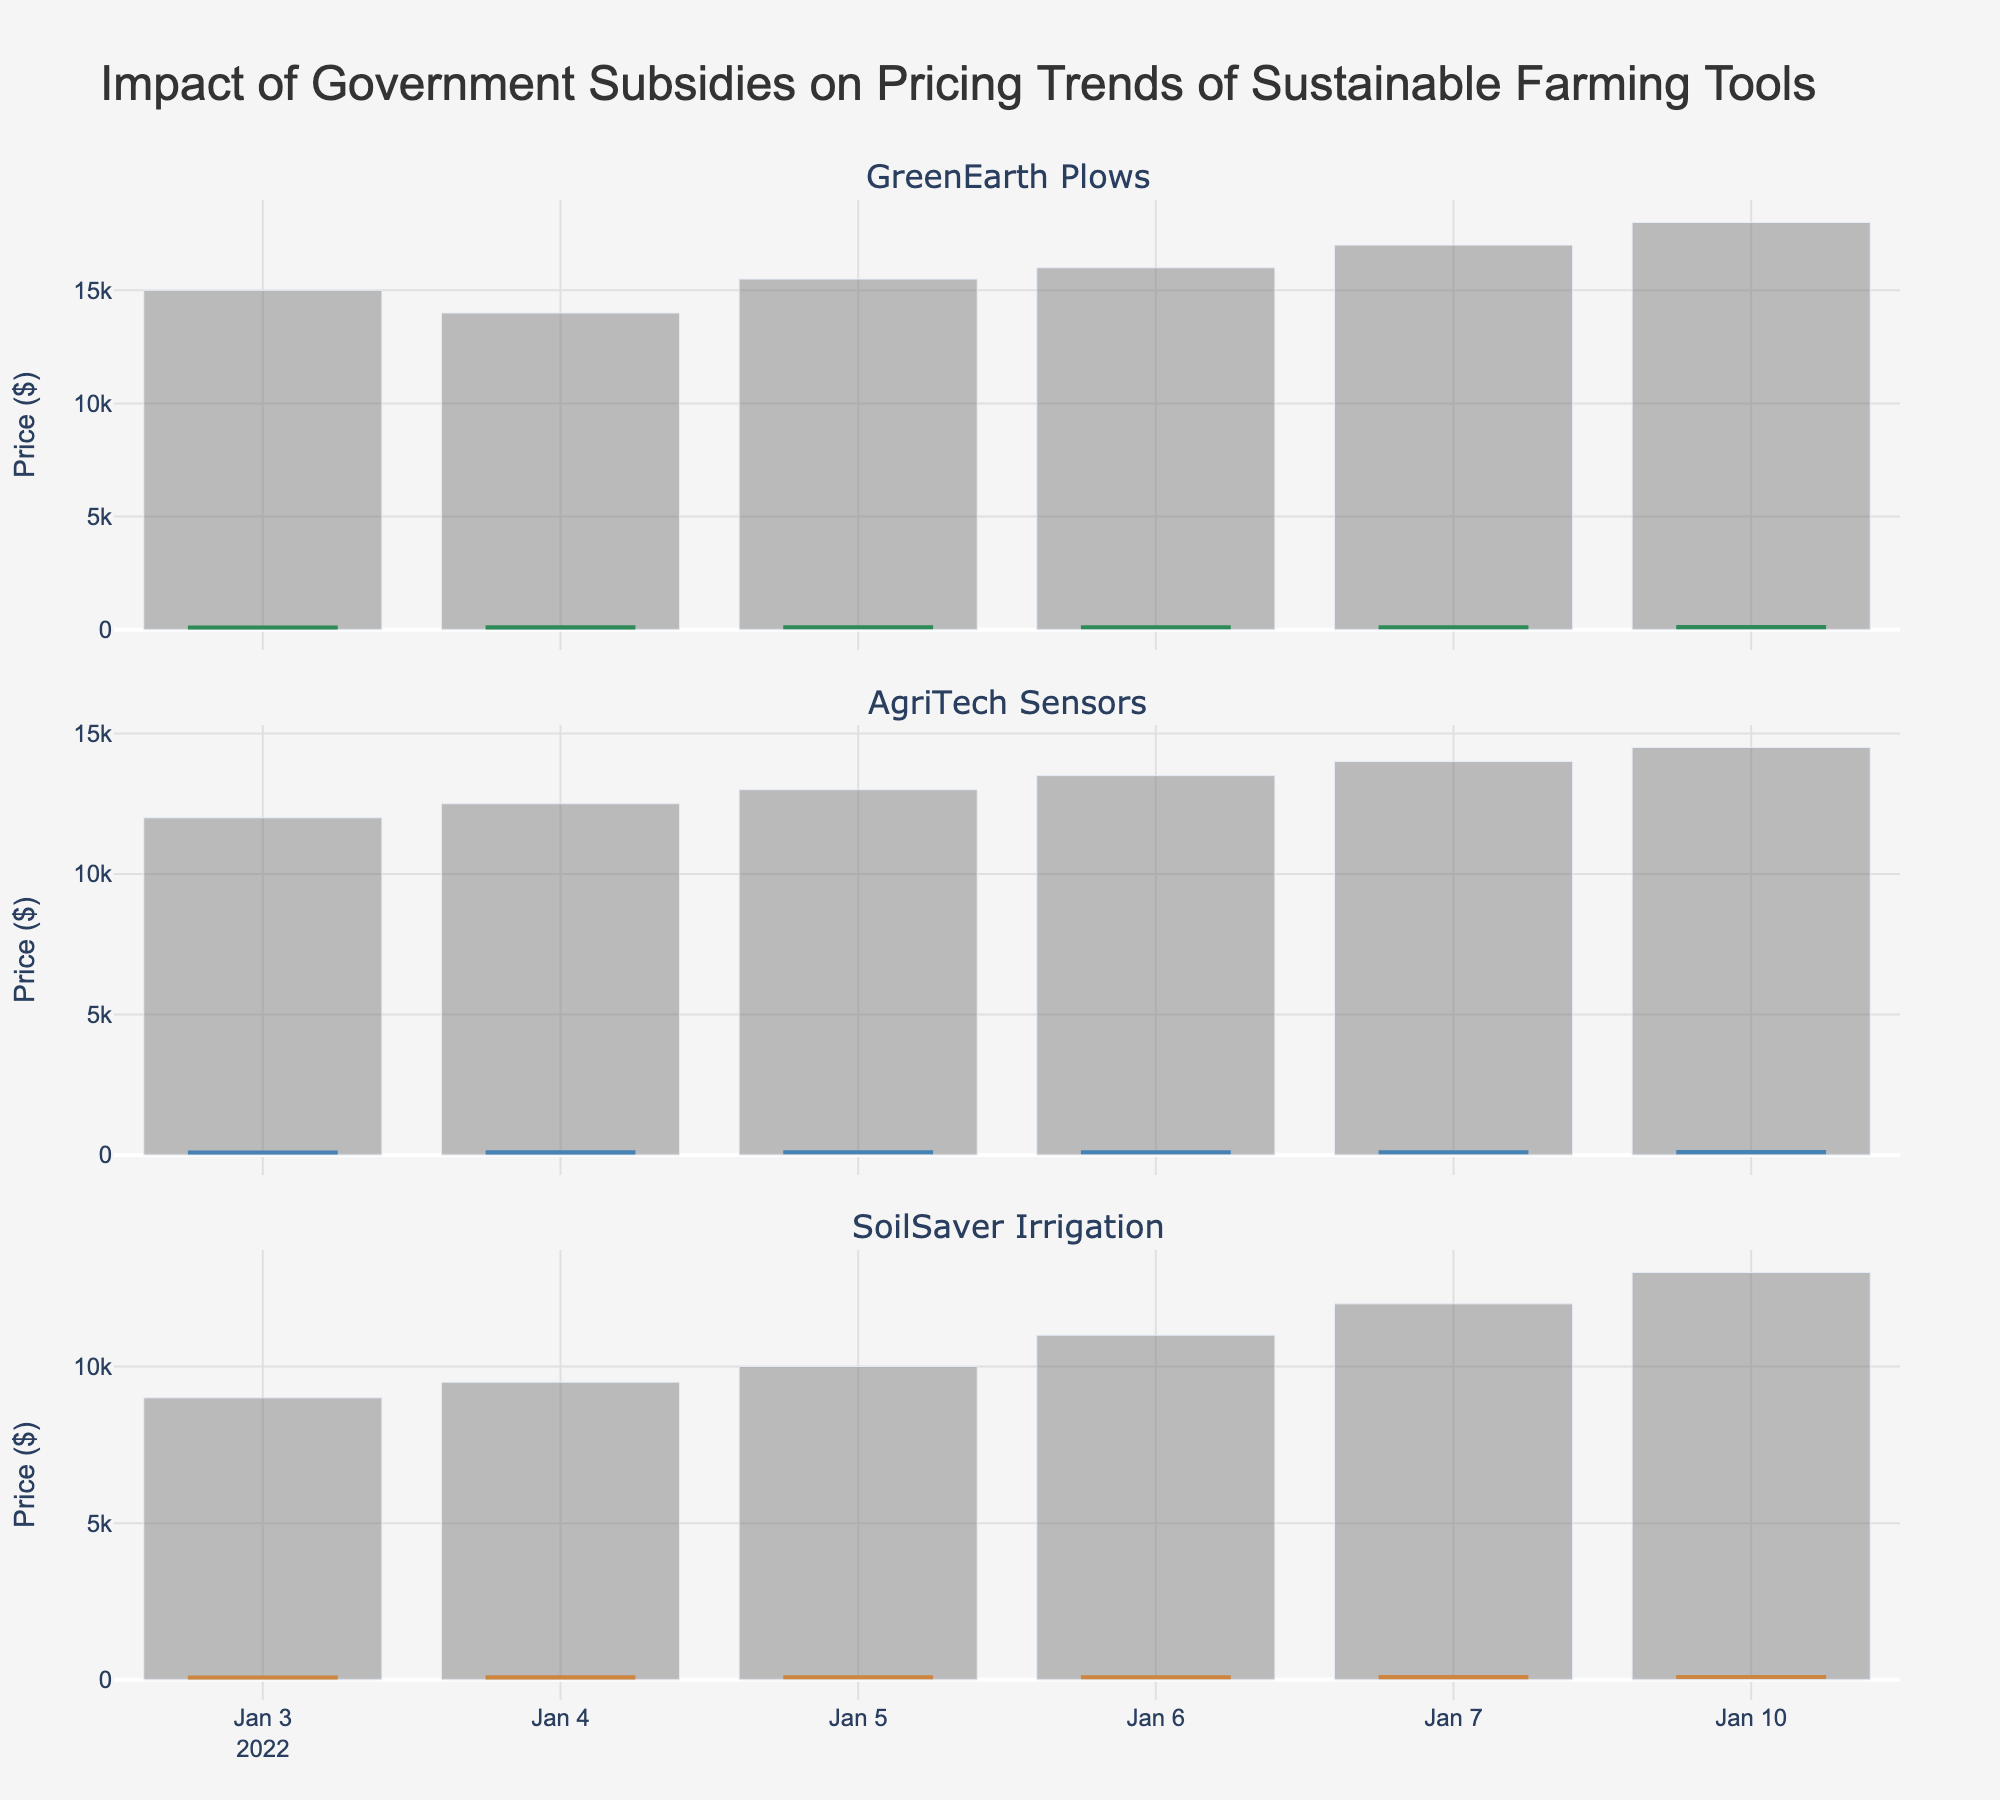What is the title of the plot? The title is generally placed at the top of the figure and is clearly visible.
Answer: Impact of Government Subsidies on Pricing Trends of Sustainable Farming Tools How many companies are shown in the figure? By counting the separate subplot titles, we can determine the number of companies.
Answer: 3 Which company had the highest closing price on January 10, 2022? By examining the closing prices for January 10, 2022, across the three subplots, we identify the highest price. For GreenEarth Plows, it is $118, for AgriTech Sensors, it is $103, and for SoilSaver Irrigation, it is $90. GreenEarth Plows has the highest closing price.
Answer: GreenEarth Plows What was the volume of trades for SoilSaver Irrigation on January 10, 2022? The volume is represented by the bars beneath the candlestick plots. By locating the bar corresponding to January 10, 2022, in the SoilSaver Irrigation subplot, we can find the volume value.
Answer: 13000 Which company showed the most consistent increase in their closing prices during the week? We need to look at the closing prices for each day of the week for all companies and identify the one that consistently increased. For GreenEarth Plows, the closing prices are 102, 107, 109, 111, 114, and 118. For AgriTech Sensors, the sequence is 92, 94, 96, 98, 100, and 103. For SoilSaver Irrigation, the numbers are 77, 79, 81, 83, 86, and 90. All three companies exhibit consistent increases, but the segment specifies to look for increasing trends, so multiple might be acceptable but GreenEarth seems to exhibit a more significant incremental rise.
Answer: GreenEarth Plows or All What was the maximum volume traded for AgriTech Sensors during the given period? We should compare each bar's height (volume) in the plot for AgriTech Sensors to find the maximum height, which corresponds to the volume. The highest bar corresponds to 14500 on January 10, 2022.
Answer: 14500 